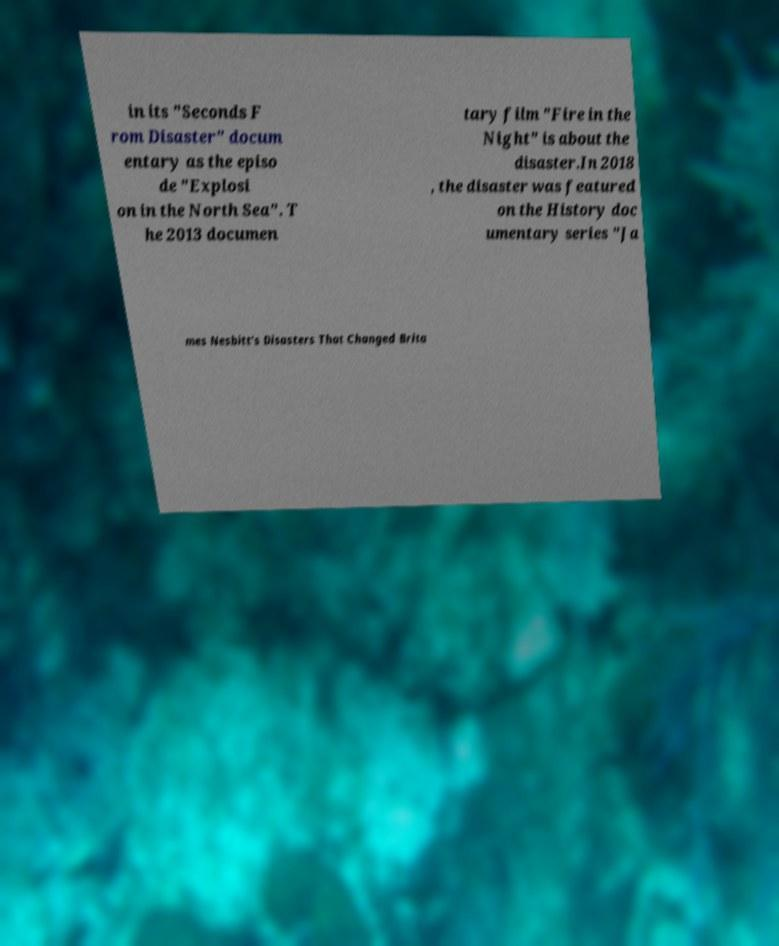I need the written content from this picture converted into text. Can you do that? in its "Seconds F rom Disaster" docum entary as the episo de "Explosi on in the North Sea". T he 2013 documen tary film "Fire in the Night" is about the disaster.In 2018 , the disaster was featured on the History doc umentary series "Ja mes Nesbitt's Disasters That Changed Brita 